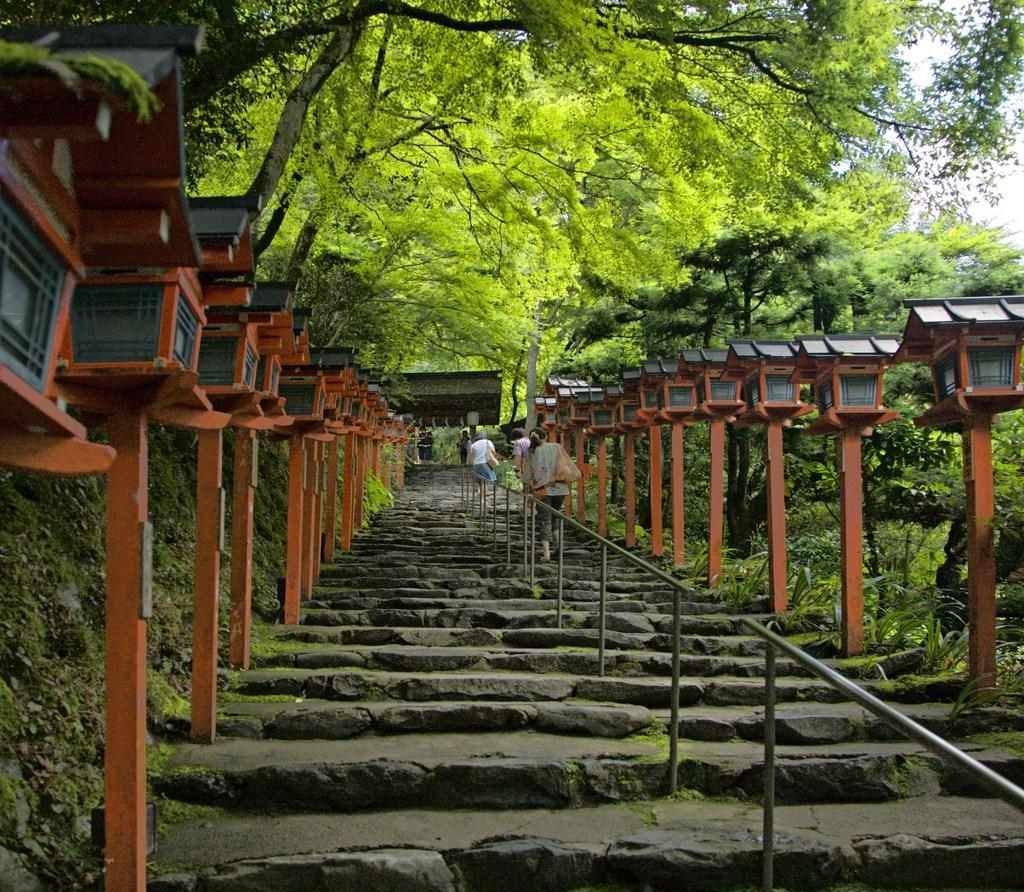What type of architectural feature is present in the image? There are stairs in the image. What safety feature is associated with the stairs? There is a railing associated with the stairs. What other objects can be seen near the stairs? There are poles visible near the stairs. What can be seen in the distance of the image? There are many trees and the sky visible in the background of the image. What type of metal is the turkey made of in the image? There is no turkey present in the image, and therefore no metal associated with it. 